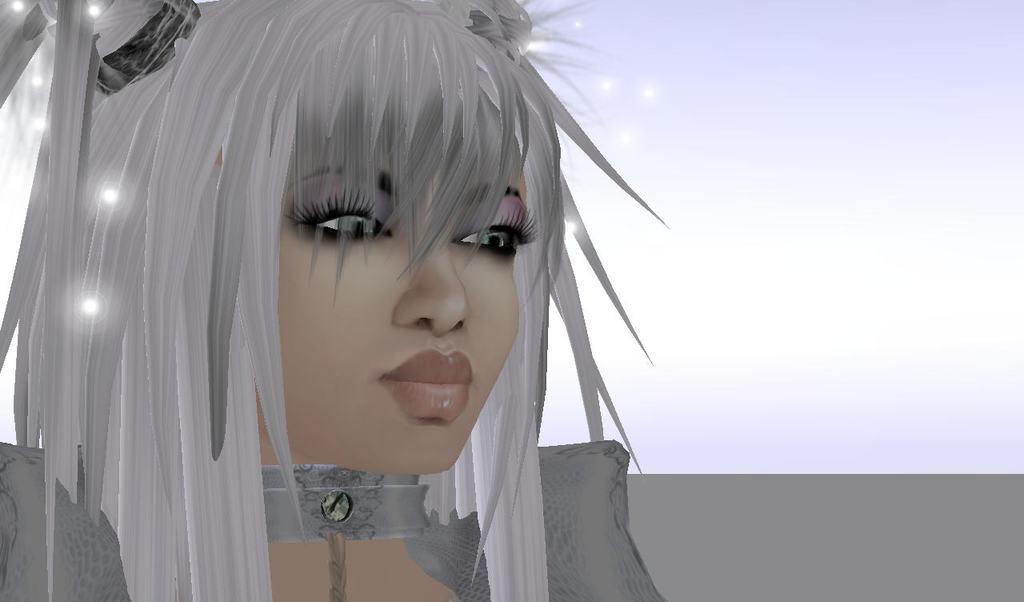Describe this image in one or two sentences. In this picture it looks like an anime image of a girl with white hair and grey dress. The background is white. 